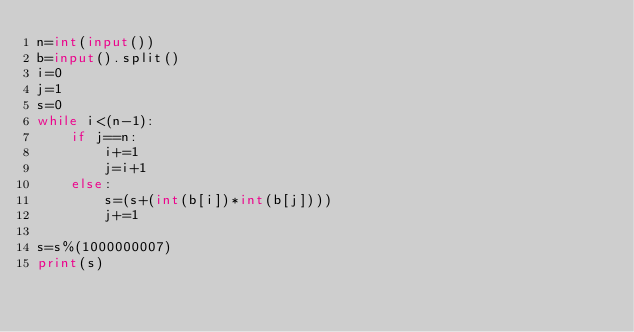Convert code to text. <code><loc_0><loc_0><loc_500><loc_500><_Python_>n=int(input())
b=input().split()
i=0
j=1
s=0
while i<(n-1):
    if j==n:
        i+=1
        j=i+1
    else:
        s=(s+(int(b[i])*int(b[j])))
        j+=1
    
s=s%(1000000007)
print(s)</code> 